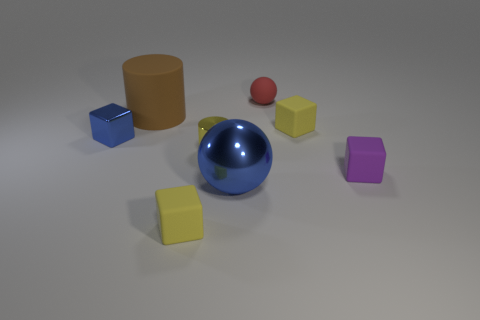What number of small metal objects have the same color as the big ball?
Keep it short and to the point. 1. Is the tiny block that is behind the tiny blue object made of the same material as the tiny blue block?
Provide a short and direct response. No. How many brown spheres are the same material as the small purple object?
Ensure brevity in your answer.  0. Are there more big balls left of the large rubber thing than rubber cylinders?
Your answer should be very brief. No. What size is the metallic thing that is the same color as the big metallic sphere?
Provide a succinct answer. Small. Are there any blue metallic things of the same shape as the small purple object?
Your response must be concise. Yes. How many things are either large blue metallic things or rubber things?
Your answer should be compact. 6. There is a tiny cube that is on the left side of the cylinder behind the metal cylinder; how many red matte objects are to the right of it?
Ensure brevity in your answer.  1. There is another thing that is the same shape as the large shiny thing; what is its material?
Provide a short and direct response. Rubber. There is a small thing that is both behind the metallic block and in front of the small sphere; what material is it?
Offer a terse response. Rubber. 